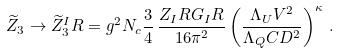Convert formula to latex. <formula><loc_0><loc_0><loc_500><loc_500>\widetilde { Z } _ { 3 } \to \widetilde { Z } _ { 3 } ^ { I } R = g ^ { 2 } N _ { c } \frac { 3 } { 4 } \, \frac { Z _ { I } R G _ { I } R } { 1 6 \pi ^ { 2 } } \left ( \frac { \Lambda _ { U } V ^ { 2 } } { \Lambda _ { Q } C D ^ { 2 } } \right ) ^ { \kappa } \, .</formula> 